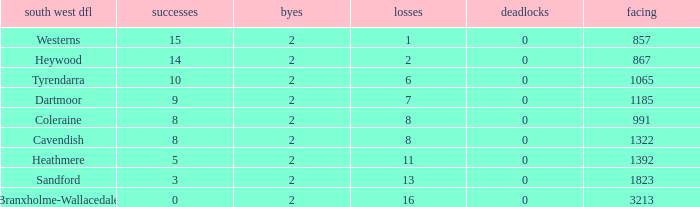How many wins have 16 losses and an Against smaller than 3213? None. 